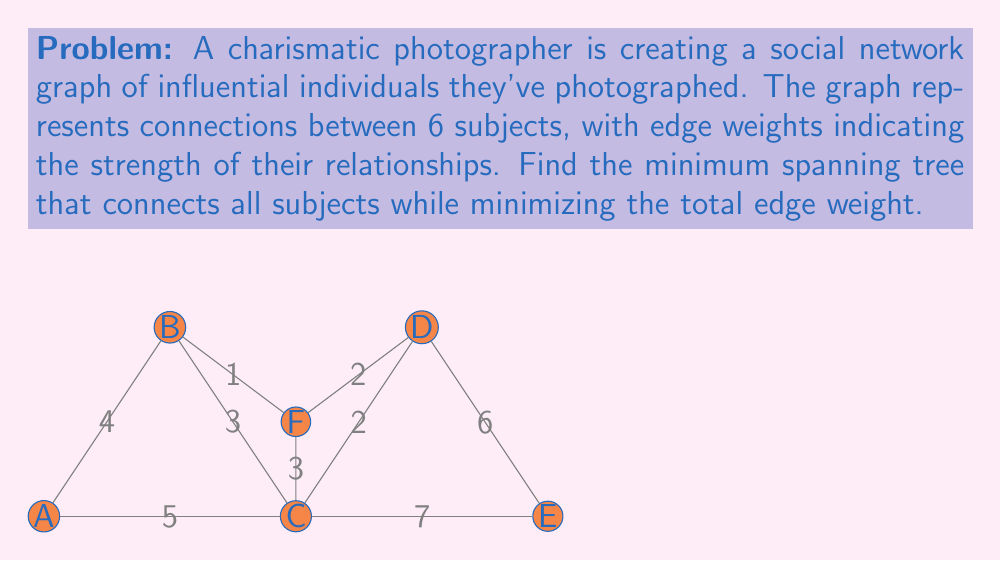Help me with this question. To find the minimum spanning tree, we'll use Kruskal's algorithm:

1) Sort edges by weight in ascending order:
   (B,F): 1, (C,D): 2, (D,F): 2, (B,C): 3, (C,F): 3, (A,B): 4, (A,C): 5, (D,E): 6, (C,E): 7

2) Add edges to the tree, skipping those that create cycles:

   - Add (B,F): 1
   - Add (C,D): 2
   - Add (D,F): 2 (creates cycle B-F-D, skip)
   - Add (B,C): 3
   - Add (C,F): 3 (creates cycle, skip)
   - Add (A,B): 4
   - Add (A,C): 5 (creates cycle, skip)
   - Add (D,E): 6

3) The minimum spanning tree is complete with 5 edges connecting all 6 vertices.

4) Calculate total weight: 1 + 2 + 3 + 4 + 6 = 16

The minimum spanning tree connects all subjects with the least total edge weight, representing the most efficient network of relationships for the photographer to navigate.
Answer: Edges: (B,F), (C,D), (B,C), (A,B), (D,E); Total weight: 16 